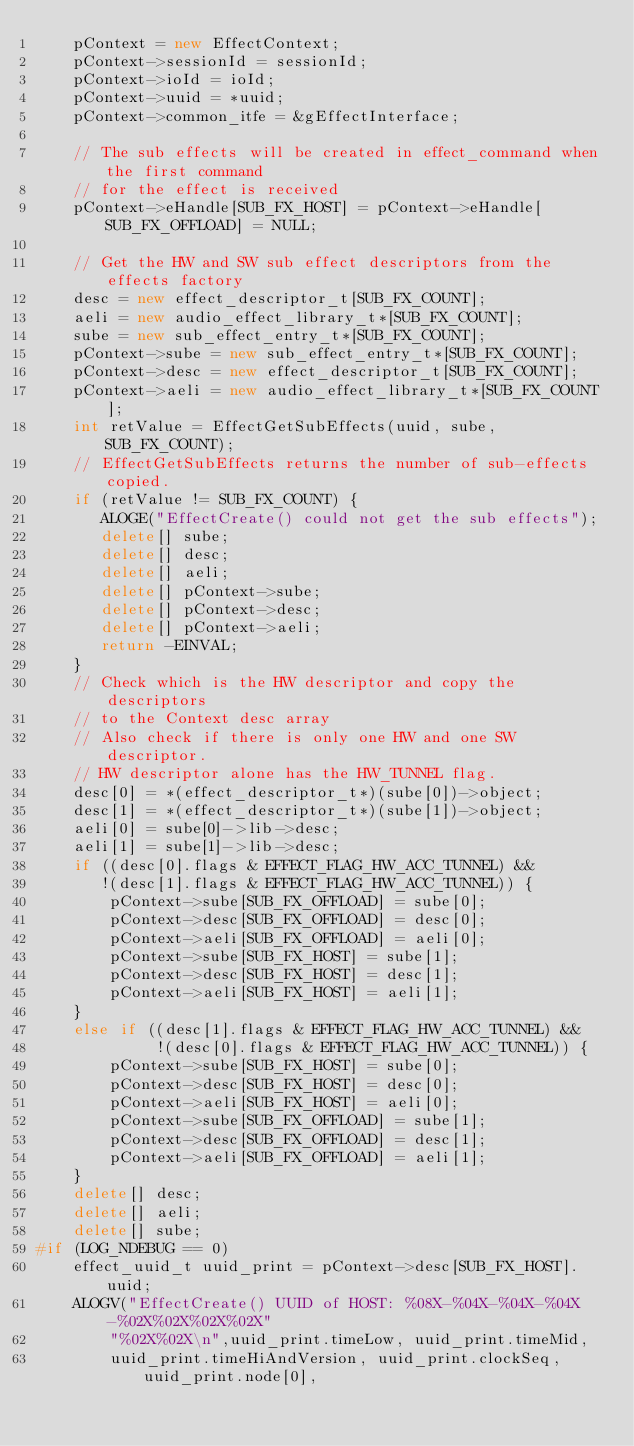<code> <loc_0><loc_0><loc_500><loc_500><_C++_>    pContext = new EffectContext;
    pContext->sessionId = sessionId;
    pContext->ioId = ioId;
    pContext->uuid = *uuid;
    pContext->common_itfe = &gEffectInterface;

    // The sub effects will be created in effect_command when the first command
    // for the effect is received
    pContext->eHandle[SUB_FX_HOST] = pContext->eHandle[SUB_FX_OFFLOAD] = NULL;

    // Get the HW and SW sub effect descriptors from the effects factory
    desc = new effect_descriptor_t[SUB_FX_COUNT];
    aeli = new audio_effect_library_t*[SUB_FX_COUNT];
    sube = new sub_effect_entry_t*[SUB_FX_COUNT];
    pContext->sube = new sub_effect_entry_t*[SUB_FX_COUNT];
    pContext->desc = new effect_descriptor_t[SUB_FX_COUNT];
    pContext->aeli = new audio_effect_library_t*[SUB_FX_COUNT];
    int retValue = EffectGetSubEffects(uuid, sube, SUB_FX_COUNT);
    // EffectGetSubEffects returns the number of sub-effects copied.
    if (retValue != SUB_FX_COUNT) {
       ALOGE("EffectCreate() could not get the sub effects");
       delete[] sube;
       delete[] desc;
       delete[] aeli;
       delete[] pContext->sube;
       delete[] pContext->desc;
       delete[] pContext->aeli;
       return -EINVAL;
    }
    // Check which is the HW descriptor and copy the descriptors
    // to the Context desc array
    // Also check if there is only one HW and one SW descriptor.
    // HW descriptor alone has the HW_TUNNEL flag.
    desc[0] = *(effect_descriptor_t*)(sube[0])->object;
    desc[1] = *(effect_descriptor_t*)(sube[1])->object;
    aeli[0] = sube[0]->lib->desc;
    aeli[1] = sube[1]->lib->desc;
    if ((desc[0].flags & EFFECT_FLAG_HW_ACC_TUNNEL) &&
       !(desc[1].flags & EFFECT_FLAG_HW_ACC_TUNNEL)) {
        pContext->sube[SUB_FX_OFFLOAD] = sube[0];
        pContext->desc[SUB_FX_OFFLOAD] = desc[0];
        pContext->aeli[SUB_FX_OFFLOAD] = aeli[0];
        pContext->sube[SUB_FX_HOST] = sube[1];
        pContext->desc[SUB_FX_HOST] = desc[1];
        pContext->aeli[SUB_FX_HOST] = aeli[1];
    }
    else if ((desc[1].flags & EFFECT_FLAG_HW_ACC_TUNNEL) &&
             !(desc[0].flags & EFFECT_FLAG_HW_ACC_TUNNEL)) {
        pContext->sube[SUB_FX_HOST] = sube[0];
        pContext->desc[SUB_FX_HOST] = desc[0];
        pContext->aeli[SUB_FX_HOST] = aeli[0];
        pContext->sube[SUB_FX_OFFLOAD] = sube[1];
        pContext->desc[SUB_FX_OFFLOAD] = desc[1];
        pContext->aeli[SUB_FX_OFFLOAD] = aeli[1];
    }
    delete[] desc;
    delete[] aeli;
    delete[] sube;
#if (LOG_NDEBUG == 0)
    effect_uuid_t uuid_print = pContext->desc[SUB_FX_HOST].uuid;
    ALOGV("EffectCreate() UUID of HOST: %08X-%04X-%04X-%04X-%02X%02X%02X%02X"
        "%02X%02X\n",uuid_print.timeLow, uuid_print.timeMid,
        uuid_print.timeHiAndVersion, uuid_print.clockSeq, uuid_print.node[0],</code> 